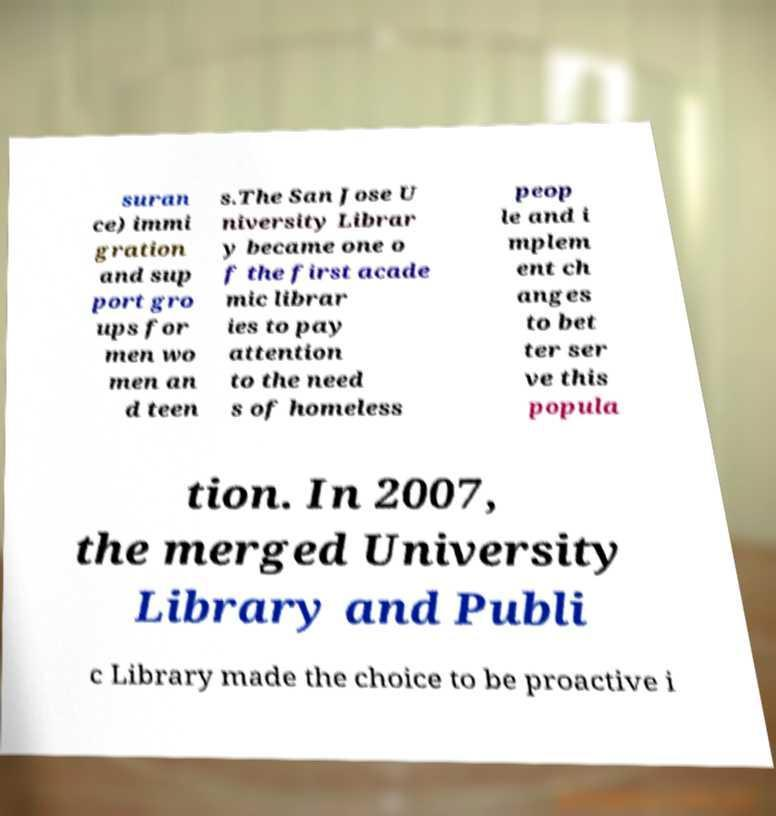Can you accurately transcribe the text from the provided image for me? suran ce) immi gration and sup port gro ups for men wo men an d teen s.The San Jose U niversity Librar y became one o f the first acade mic librar ies to pay attention to the need s of homeless peop le and i mplem ent ch anges to bet ter ser ve this popula tion. In 2007, the merged University Library and Publi c Library made the choice to be proactive i 